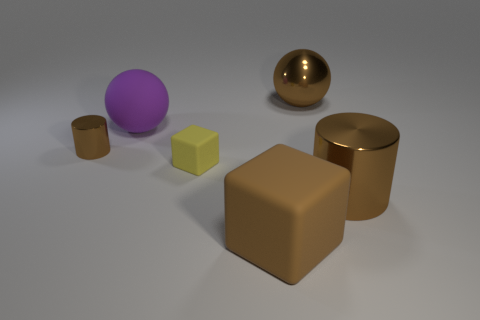Subtract all purple spheres. How many spheres are left? 1 Subtract 1 brown cubes. How many objects are left? 5 Subtract 1 spheres. How many spheres are left? 1 Subtract all green balls. Subtract all cyan blocks. How many balls are left? 2 Subtract all purple cylinders. How many brown cubes are left? 1 Subtract all big brown matte cubes. Subtract all small objects. How many objects are left? 3 Add 3 big metallic balls. How many big metallic balls are left? 4 Add 2 brown shiny things. How many brown shiny things exist? 5 Add 2 cyan rubber blocks. How many objects exist? 8 